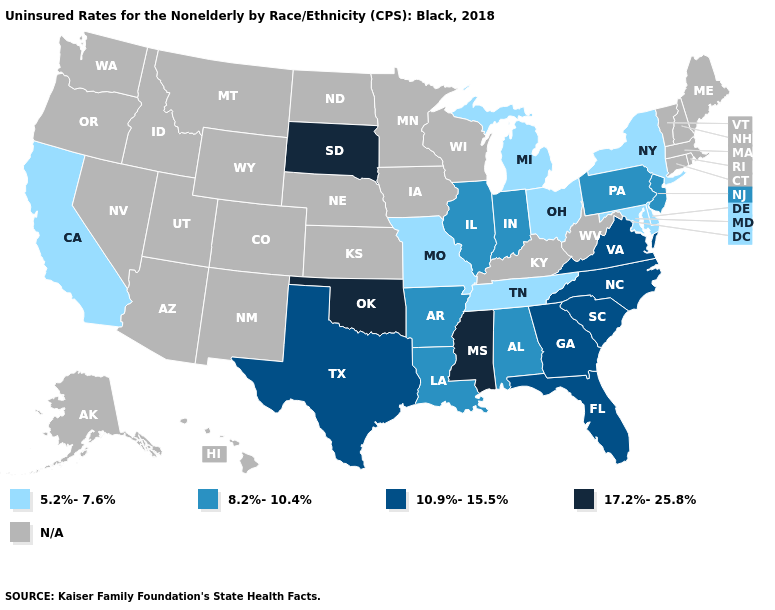What is the value of Wisconsin?
Be succinct. N/A. Does South Dakota have the highest value in the MidWest?
Keep it brief. Yes. Which states hav the highest value in the South?
Quick response, please. Mississippi, Oklahoma. Is the legend a continuous bar?
Keep it brief. No. What is the value of Kansas?
Give a very brief answer. N/A. Among the states that border Ohio , does Michigan have the highest value?
Write a very short answer. No. Which states have the lowest value in the USA?
Keep it brief. California, Delaware, Maryland, Michigan, Missouri, New York, Ohio, Tennessee. Is the legend a continuous bar?
Give a very brief answer. No. Name the states that have a value in the range 5.2%-7.6%?
Keep it brief. California, Delaware, Maryland, Michigan, Missouri, New York, Ohio, Tennessee. What is the lowest value in the Northeast?
Answer briefly. 5.2%-7.6%. Does Ohio have the highest value in the MidWest?
Answer briefly. No. Name the states that have a value in the range 5.2%-7.6%?
Be succinct. California, Delaware, Maryland, Michigan, Missouri, New York, Ohio, Tennessee. What is the value of Utah?
Short answer required. N/A. 